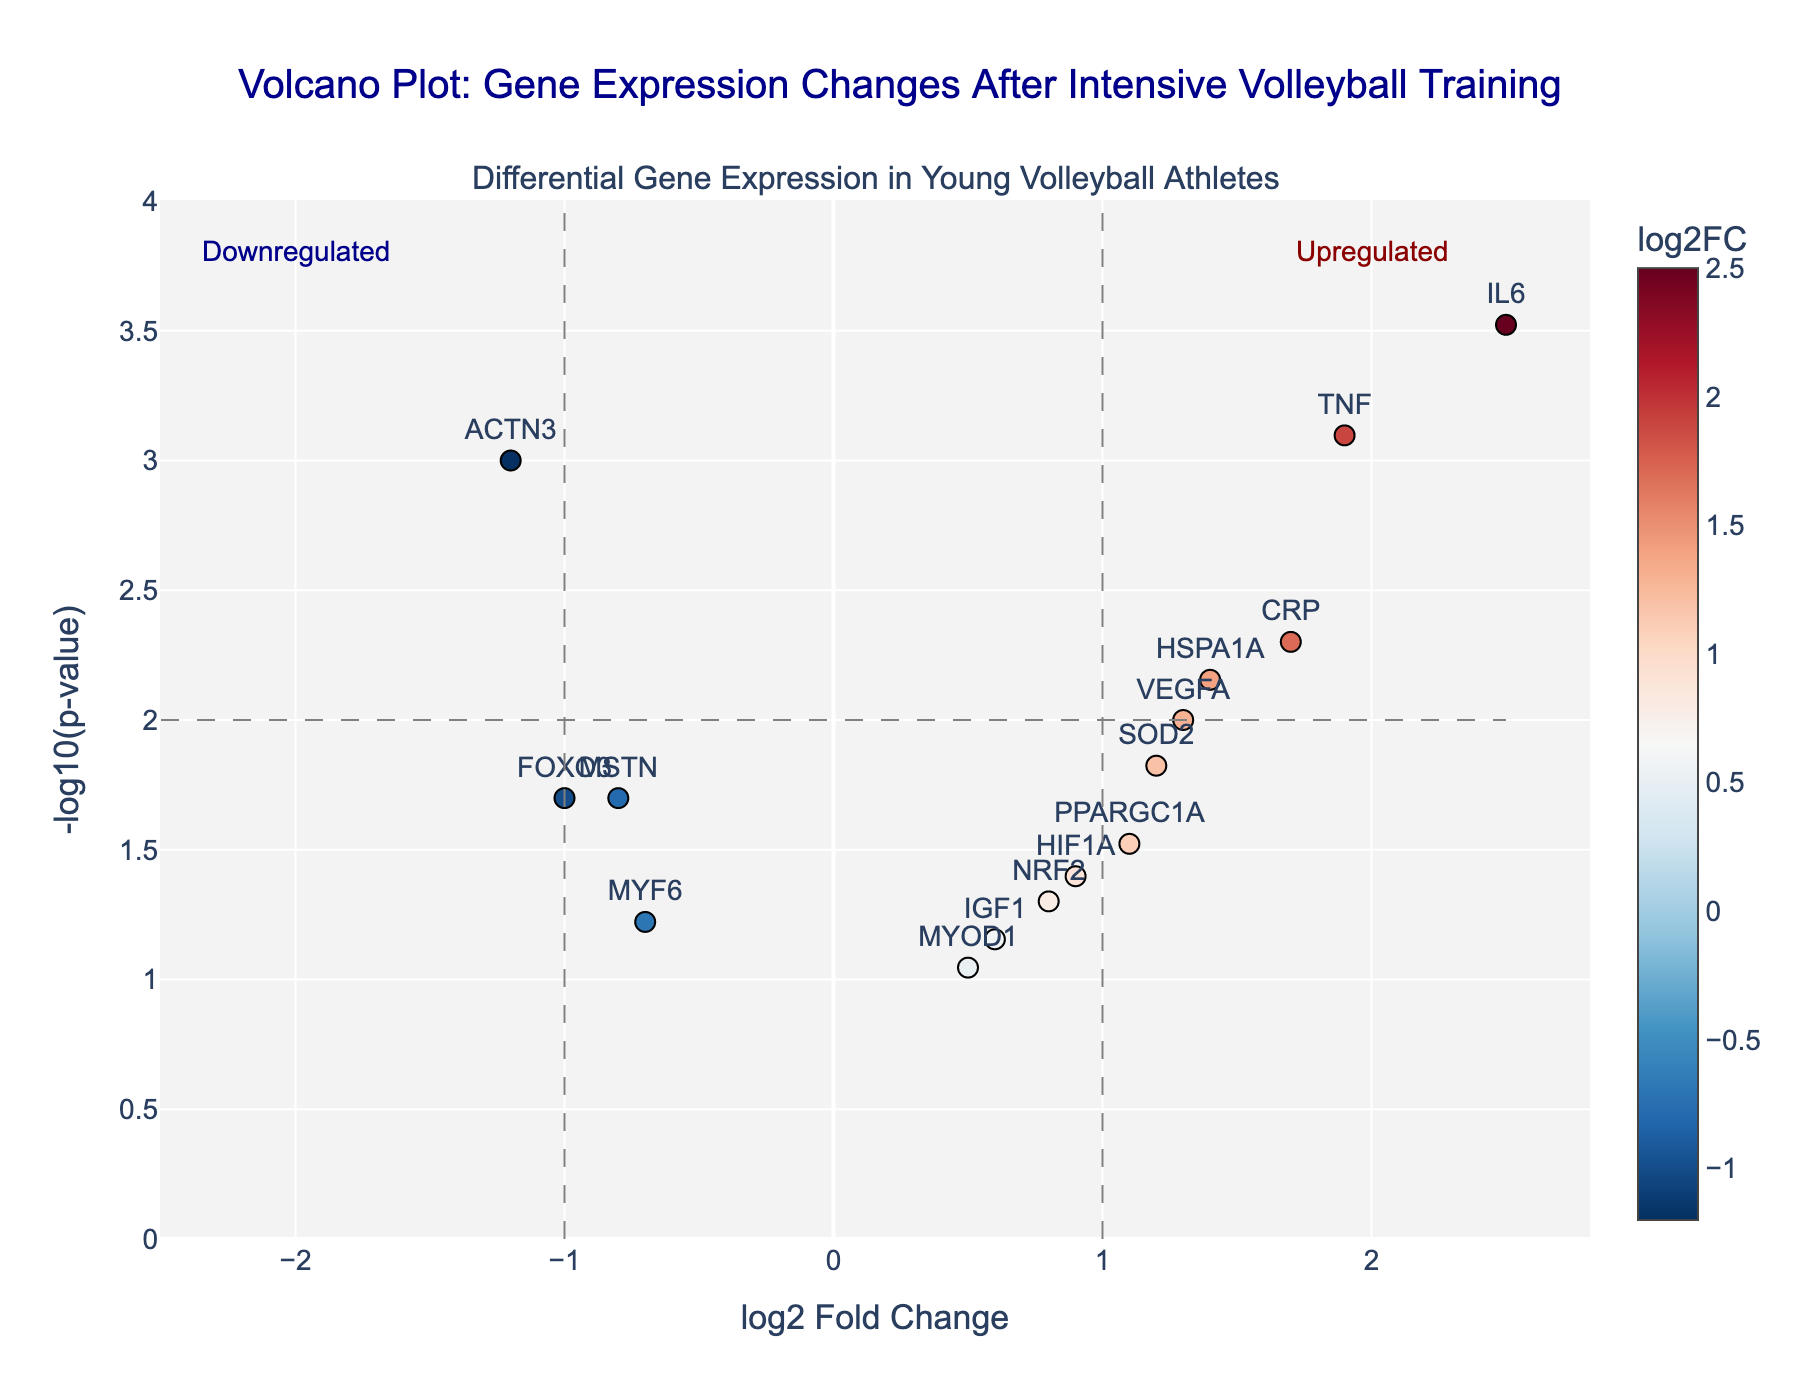What is the title of the plot? The title is typically located at the top of the plot. It provides an overview of what the plot is about. In this case, it reads "Volcano Plot: Gene Expression Changes After Intensive Volleyball Training".
Answer: "Volcano Plot: Gene Expression Changes After Intensive Volleyball Training" What are the x-axis and y-axis labels? The axis labels are found along the horizontal and vertical axes of the plot. The x-axis is labeled "log2 Fold Change" and the y-axis is labeled "-log10(p-value)".
Answer: "log2 Fold Change" for x-axis and "-log10(p-value)" for y-axis How many genes are significantly upregulated (log2FC > 1 and p-value < 0.01)? To answer this, we need to identify the genes with log2FC values greater than 1 and p-values less than 0.01. IL6 (2.5, 0.0003) and TNF (1.9, 0.0008) meet these criteria.
Answer: 2 genes (IL6, TNF) Which gene has the most significant p-value? The significance of a p-value is determined by how low it is. The gene IL6 has the lowest p-value of 0.0003, making it the most significant.
Answer: IL6 Which genes are downregulated (log2FC < 0)? To determine this, we look for genes with log2FC values less than 0: ACTN3 (-1.2), MSTN (-0.8), FOXO3 (-1.0), MYF6 (-0.7).
Answer: ACTN3, MSTN, FOXO3, MYF6 What is the log2 fold change of VEGFA? Find VEGFA on the plot by its text label, then refer to the x-axis position to obtain its log2 fold change, which is 1.3.
Answer: 1.3 Compare the expression changes of CRP and HSPA1A. Which one is more significant and by how much? Compare the -log10(p-value) of both genes to determine significance. CRP has a -log10(p-value) of 2.3 (p-value 0.005) and HSPA1A has -log10(p-value) of 2.15 (p-value 0.007). The difference is 0.15.
Answer: CRP by 0.15 What area represents genes that are significantly upregulated on the volcano plot? The region representing significantly upregulated genes is defined by log2FC > 1 (vertical line at x = 1) and -log10(p-value) > 2 (horizontal line at y = 2), located in the top right quadrant of the plot.
Answer: Top right quadrant Are there any genes with a log2 fold change between -1 and 1 and with a p-value less than 0.05? We look for genes within the range -1 < log2FC < 1 and -log10(p-value) > 1.3. IGF1 (0.6, 0.07) and MYOD1 (0.5, 0.09) do not meet the p-value criteria as theirs exceed 0.05. The other genes that fit the range have p-values less than 0.05.
Answer: No 